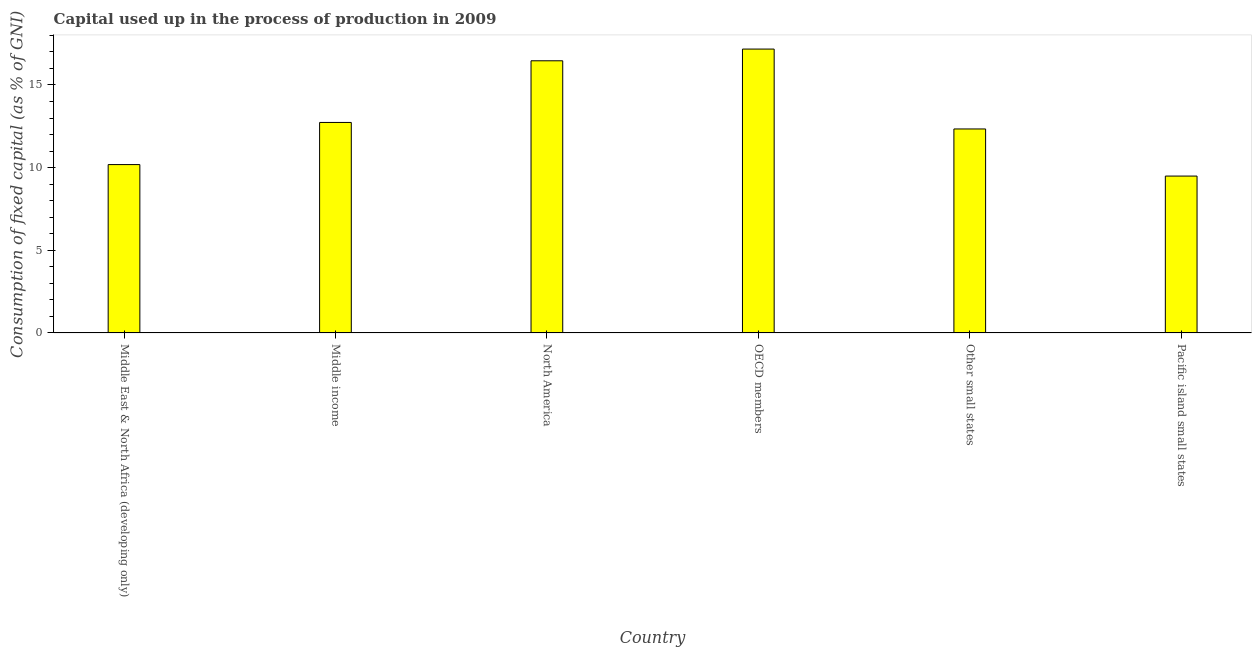Does the graph contain any zero values?
Your response must be concise. No. What is the title of the graph?
Your response must be concise. Capital used up in the process of production in 2009. What is the label or title of the X-axis?
Keep it short and to the point. Country. What is the label or title of the Y-axis?
Offer a terse response. Consumption of fixed capital (as % of GNI). What is the consumption of fixed capital in Middle income?
Provide a short and direct response. 12.73. Across all countries, what is the maximum consumption of fixed capital?
Provide a succinct answer. 17.17. Across all countries, what is the minimum consumption of fixed capital?
Your answer should be very brief. 9.49. In which country was the consumption of fixed capital minimum?
Provide a succinct answer. Pacific island small states. What is the sum of the consumption of fixed capital?
Your response must be concise. 78.38. What is the difference between the consumption of fixed capital in Middle income and OECD members?
Provide a succinct answer. -4.44. What is the average consumption of fixed capital per country?
Offer a very short reply. 13.06. What is the median consumption of fixed capital?
Your response must be concise. 12.54. In how many countries, is the consumption of fixed capital greater than 14 %?
Your answer should be very brief. 2. What is the ratio of the consumption of fixed capital in Middle income to that in Pacific island small states?
Give a very brief answer. 1.34. What is the difference between the highest and the second highest consumption of fixed capital?
Offer a very short reply. 0.71. Is the sum of the consumption of fixed capital in North America and Other small states greater than the maximum consumption of fixed capital across all countries?
Your answer should be compact. Yes. What is the difference between the highest and the lowest consumption of fixed capital?
Offer a terse response. 7.68. In how many countries, is the consumption of fixed capital greater than the average consumption of fixed capital taken over all countries?
Provide a short and direct response. 2. How many bars are there?
Keep it short and to the point. 6. Are all the bars in the graph horizontal?
Offer a terse response. No. What is the Consumption of fixed capital (as % of GNI) in Middle East & North Africa (developing only)?
Keep it short and to the point. 10.18. What is the Consumption of fixed capital (as % of GNI) in Middle income?
Provide a short and direct response. 12.73. What is the Consumption of fixed capital (as % of GNI) in North America?
Offer a very short reply. 16.46. What is the Consumption of fixed capital (as % of GNI) in OECD members?
Your answer should be very brief. 17.17. What is the Consumption of fixed capital (as % of GNI) of Other small states?
Ensure brevity in your answer.  12.34. What is the Consumption of fixed capital (as % of GNI) in Pacific island small states?
Keep it short and to the point. 9.49. What is the difference between the Consumption of fixed capital (as % of GNI) in Middle East & North Africa (developing only) and Middle income?
Your response must be concise. -2.55. What is the difference between the Consumption of fixed capital (as % of GNI) in Middle East & North Africa (developing only) and North America?
Your answer should be very brief. -6.28. What is the difference between the Consumption of fixed capital (as % of GNI) in Middle East & North Africa (developing only) and OECD members?
Give a very brief answer. -6.99. What is the difference between the Consumption of fixed capital (as % of GNI) in Middle East & North Africa (developing only) and Other small states?
Your answer should be compact. -2.16. What is the difference between the Consumption of fixed capital (as % of GNI) in Middle East & North Africa (developing only) and Pacific island small states?
Offer a terse response. 0.69. What is the difference between the Consumption of fixed capital (as % of GNI) in Middle income and North America?
Your answer should be very brief. -3.73. What is the difference between the Consumption of fixed capital (as % of GNI) in Middle income and OECD members?
Offer a terse response. -4.44. What is the difference between the Consumption of fixed capital (as % of GNI) in Middle income and Other small states?
Your answer should be very brief. 0.39. What is the difference between the Consumption of fixed capital (as % of GNI) in Middle income and Pacific island small states?
Your answer should be very brief. 3.24. What is the difference between the Consumption of fixed capital (as % of GNI) in North America and OECD members?
Ensure brevity in your answer.  -0.71. What is the difference between the Consumption of fixed capital (as % of GNI) in North America and Other small states?
Your answer should be very brief. 4.12. What is the difference between the Consumption of fixed capital (as % of GNI) in North America and Pacific island small states?
Your answer should be very brief. 6.97. What is the difference between the Consumption of fixed capital (as % of GNI) in OECD members and Other small states?
Give a very brief answer. 4.83. What is the difference between the Consumption of fixed capital (as % of GNI) in OECD members and Pacific island small states?
Make the answer very short. 7.68. What is the difference between the Consumption of fixed capital (as % of GNI) in Other small states and Pacific island small states?
Offer a terse response. 2.85. What is the ratio of the Consumption of fixed capital (as % of GNI) in Middle East & North Africa (developing only) to that in North America?
Provide a succinct answer. 0.62. What is the ratio of the Consumption of fixed capital (as % of GNI) in Middle East & North Africa (developing only) to that in OECD members?
Provide a succinct answer. 0.59. What is the ratio of the Consumption of fixed capital (as % of GNI) in Middle East & North Africa (developing only) to that in Other small states?
Ensure brevity in your answer.  0.82. What is the ratio of the Consumption of fixed capital (as % of GNI) in Middle East & North Africa (developing only) to that in Pacific island small states?
Ensure brevity in your answer.  1.07. What is the ratio of the Consumption of fixed capital (as % of GNI) in Middle income to that in North America?
Your response must be concise. 0.77. What is the ratio of the Consumption of fixed capital (as % of GNI) in Middle income to that in OECD members?
Make the answer very short. 0.74. What is the ratio of the Consumption of fixed capital (as % of GNI) in Middle income to that in Other small states?
Keep it short and to the point. 1.03. What is the ratio of the Consumption of fixed capital (as % of GNI) in Middle income to that in Pacific island small states?
Offer a terse response. 1.34. What is the ratio of the Consumption of fixed capital (as % of GNI) in North America to that in OECD members?
Provide a succinct answer. 0.96. What is the ratio of the Consumption of fixed capital (as % of GNI) in North America to that in Other small states?
Ensure brevity in your answer.  1.33. What is the ratio of the Consumption of fixed capital (as % of GNI) in North America to that in Pacific island small states?
Give a very brief answer. 1.74. What is the ratio of the Consumption of fixed capital (as % of GNI) in OECD members to that in Other small states?
Provide a succinct answer. 1.39. What is the ratio of the Consumption of fixed capital (as % of GNI) in OECD members to that in Pacific island small states?
Give a very brief answer. 1.81. 